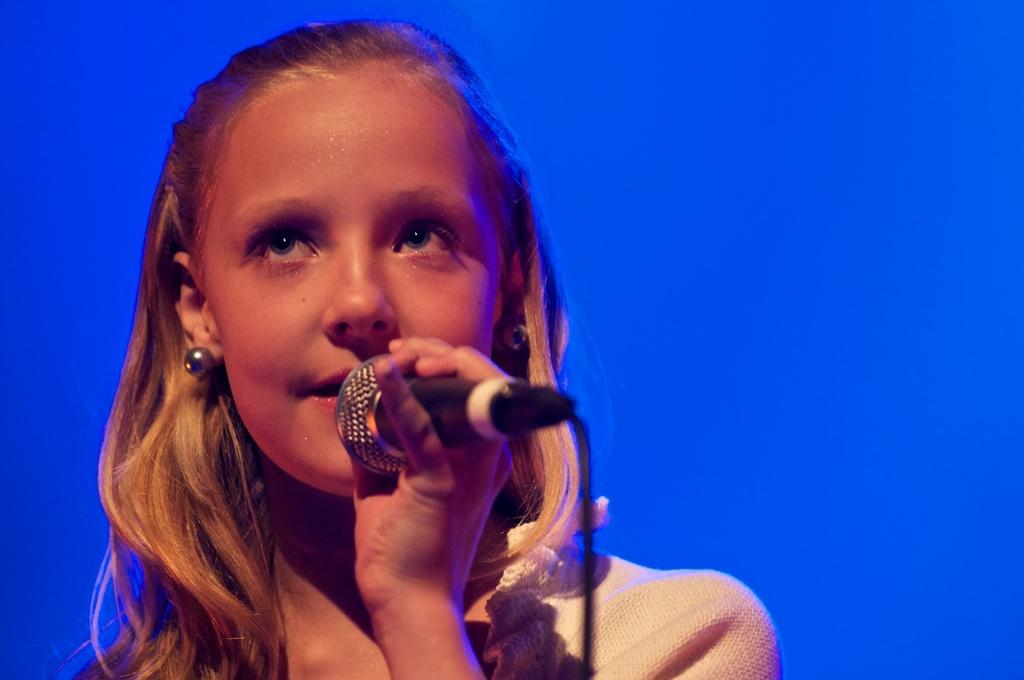Who is the main subject in the picture? There is a girl in the picture. What is the girl holding in the picture? The girl is holding a microphone. What type of crayon is the girl using to draw in the picture? There is no crayon present in the picture, and the girl is not drawing. 